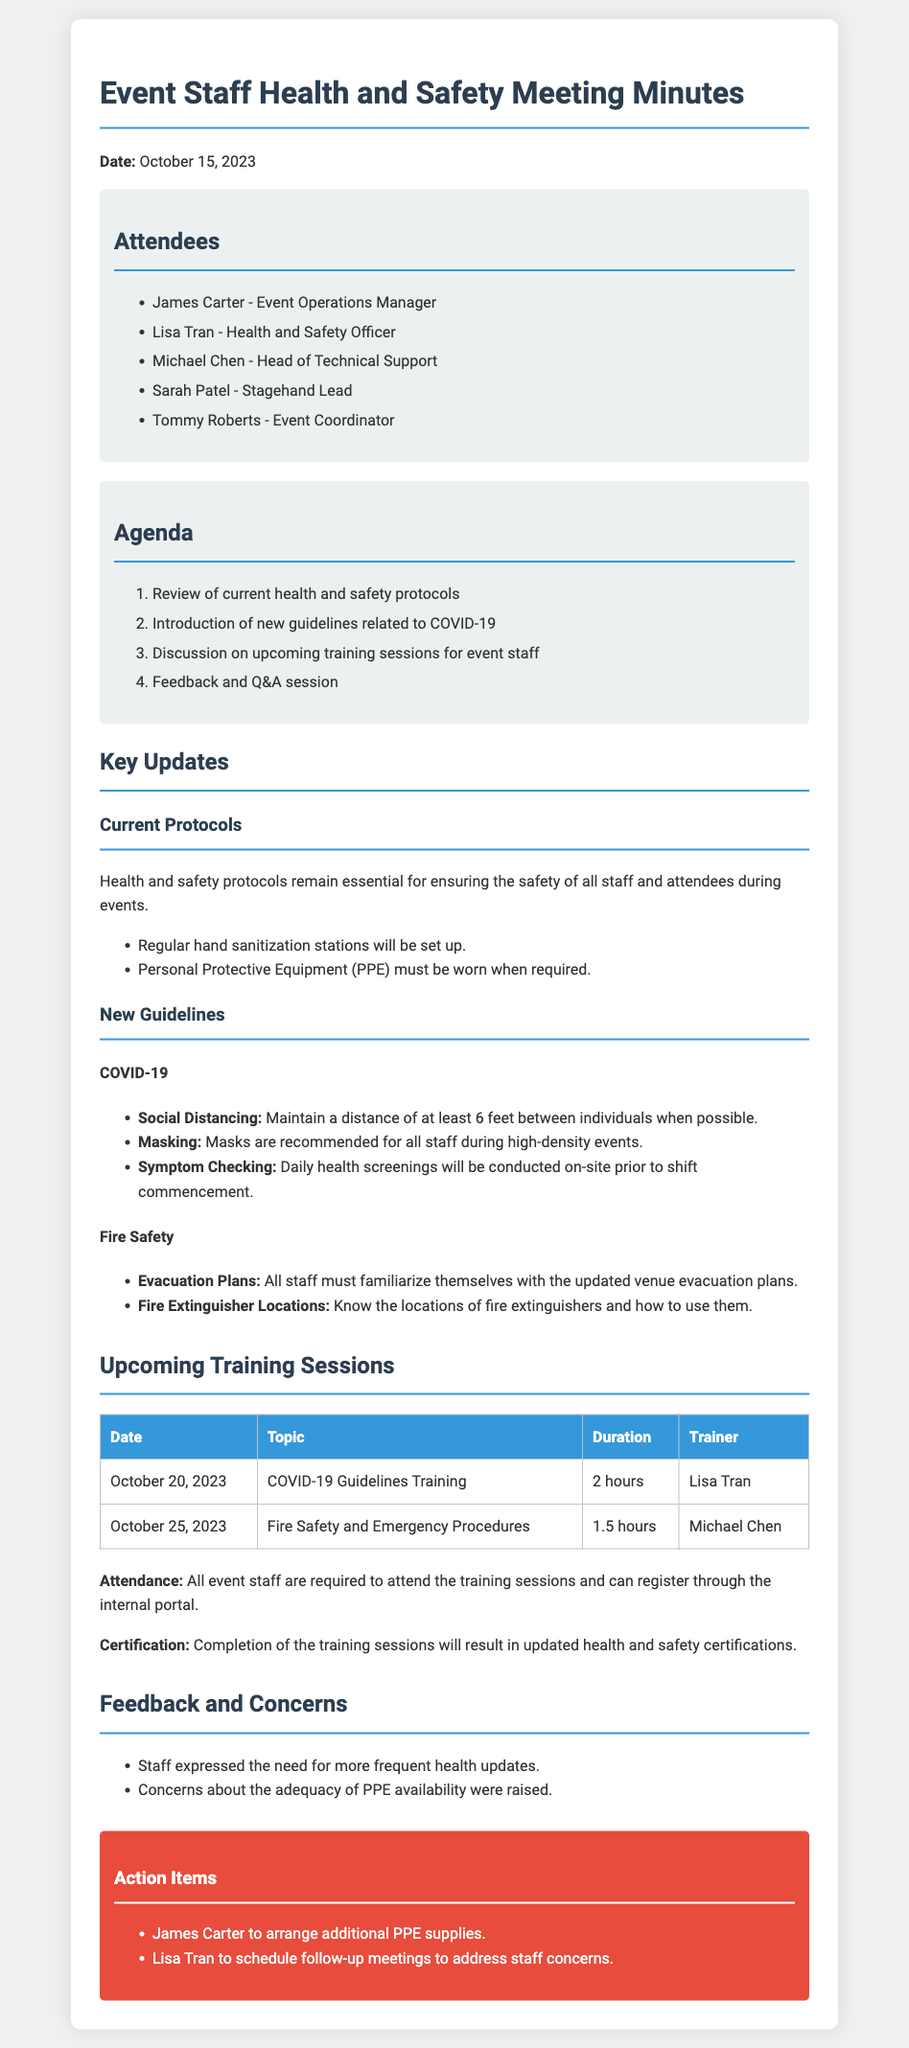What is the date of the meeting? The date of the meeting is explicitly stated in the document under the date section.
Answer: October 15, 2023 Who is the Health and Safety Officer? The document lists the attendees, including their roles, and identifies Lisa Tran as the Health and Safety Officer.
Answer: Lisa Tran What topic will be covered in the training session on October 20, 2023? The table in the document outlines the upcoming training sessions and their topics, specifying the topic for that date.
Answer: COVID-19 Guidelines Training How long is the Fire Safety and Emergency Procedures training session? The duration for the Fire Safety training is provided in the training sessions table within the document.
Answer: 1.5 hours What is one of the key updates related to COVID-19? The document lists new guidelines regarding COVID-19, and one of those guidelines is specified as an example.
Answer: Daily health screenings What action will James Carter take? The action items section specifies what actions individuals are responsible for following the meeting, particularly for James Carter.
Answer: Arrange additional PPE supplies What feedback was expressed by the staff? The feedback section contains specific feedback provided by staff, which is summarized in the list.
Answer: Need for more frequent health updates Who will conduct the training on Fire Safety? The document assigns the training sessions to specific trainers, indicating who is responsible for the Fire Safety training.
Answer: Michael Chen 